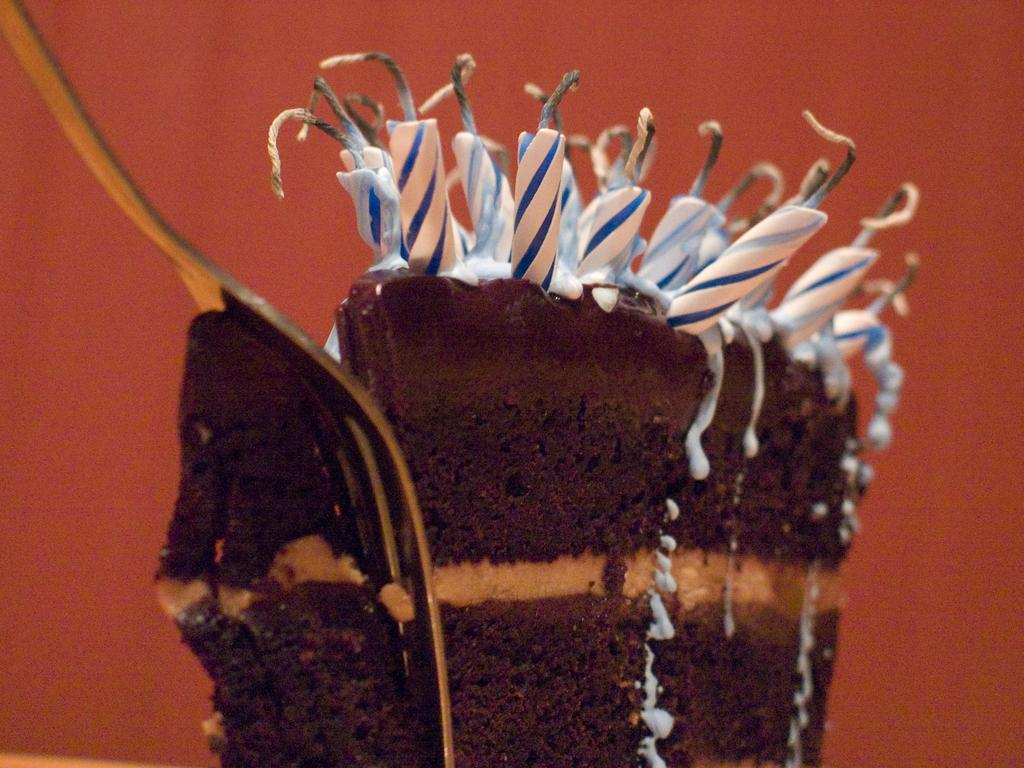What type of food item is present in the image? There is a pastry in the image. What is placed on top of the pastry? There are candles on top of the pastry. Can you describe the candles' appearance? The candles have wax visible on them. What color can be seen in the background of the image? The background of the image has a bronze color. What utensil is located on the left side of the image? There is a fork on the left side of the image. What type of gate can be seen in the image? There is no gate present in the image. What type of beef dish is being served with the pastry in the image? There is no beef dish present in the image. 